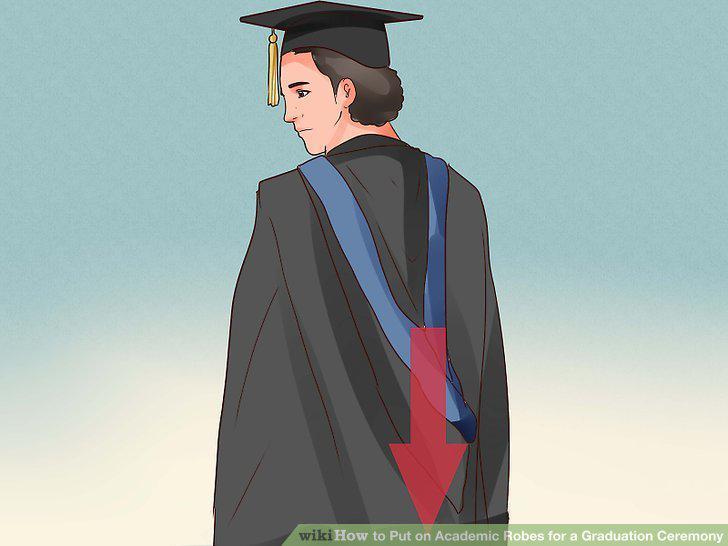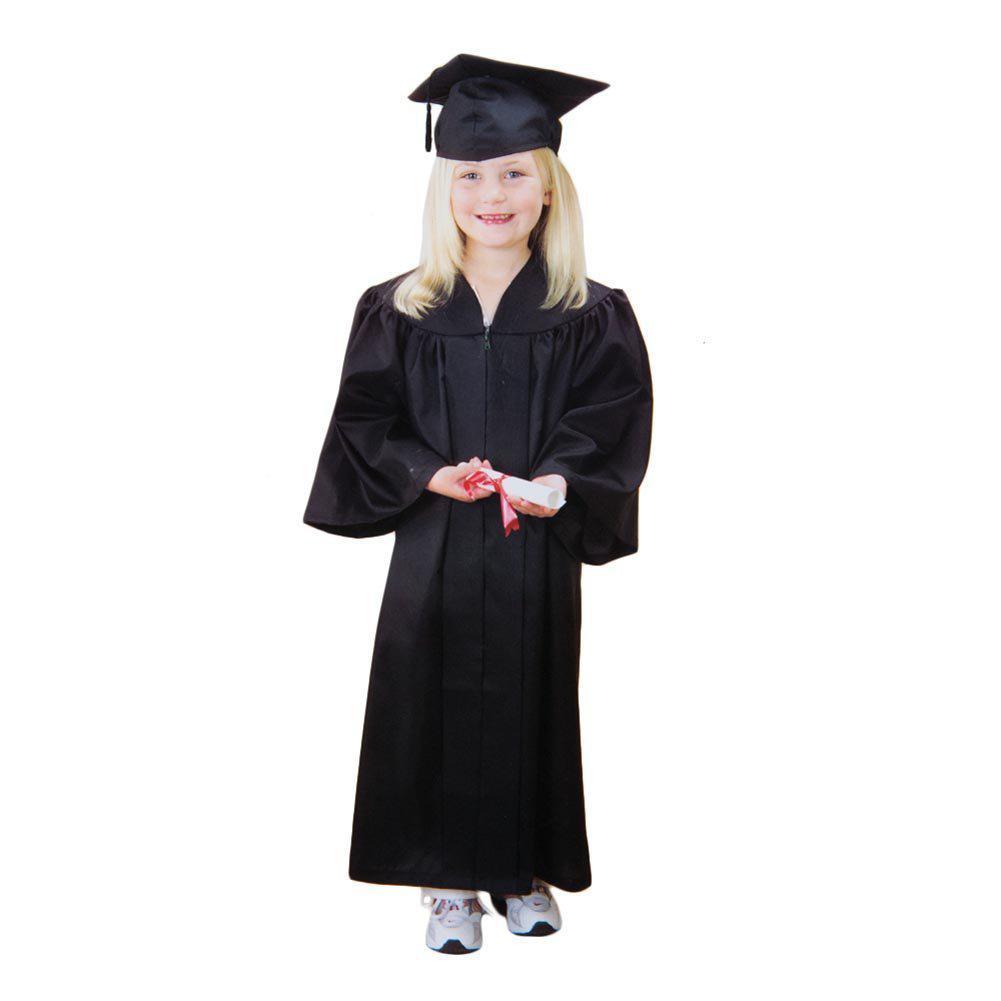The first image is the image on the left, the second image is the image on the right. For the images shown, is this caption "At least one gown in the pair has a yellow part to the sash." true? Answer yes or no. No. 